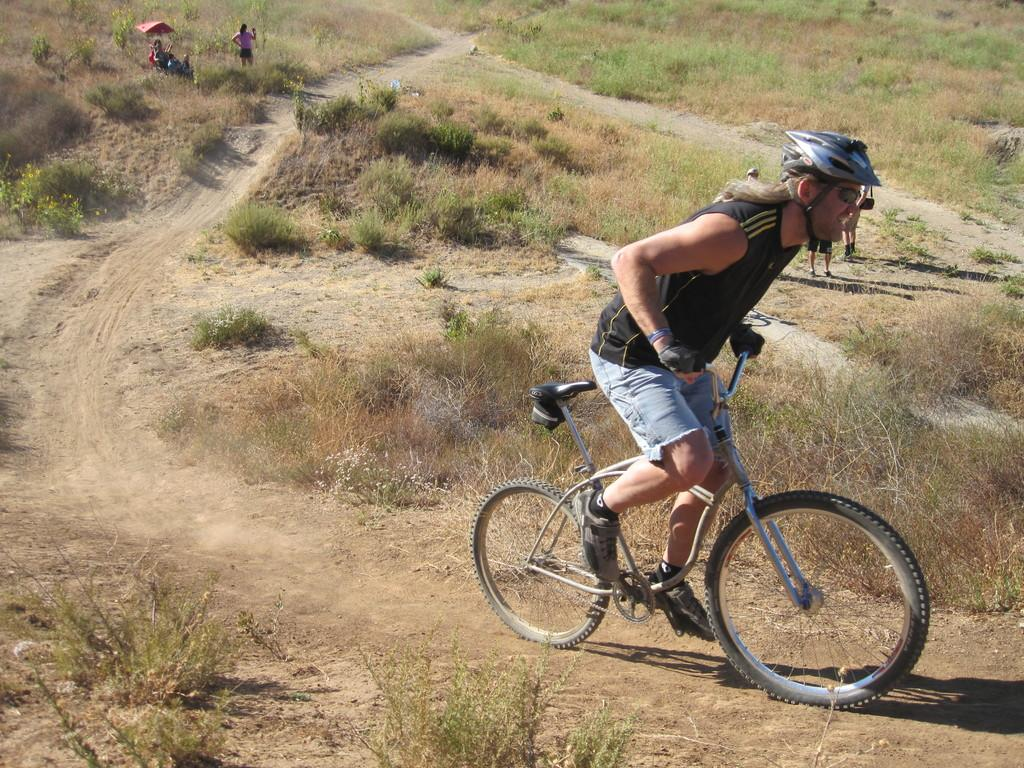What is the person in the image doing? The person is riding a bicycle in the image. What is the person wearing while riding the bicycle? The person is wearing a helmet. Where is the bicycle located in the image? The bicycle is on a hill area. What can be seen in the background of the image? There are people and plants in the background of the image. What type of writing can be seen on the helmet in the image? There is no writing visible on the helmet in the image. What reward is the person receiving for riding the bicycle on the hill? There is no indication of a reward in the image; the person is simply riding a bicycle. 